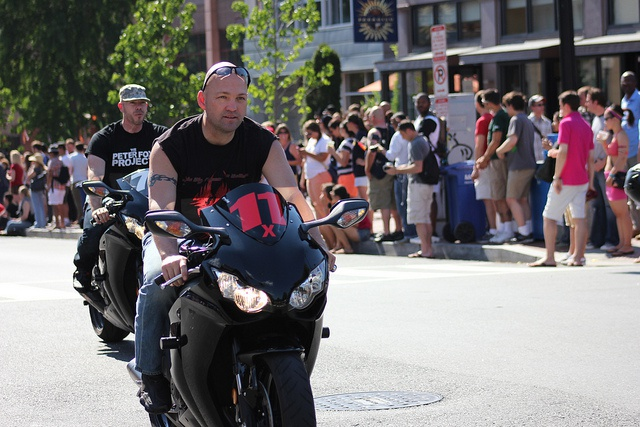Describe the objects in this image and their specific colors. I can see motorcycle in black, gray, navy, and white tones, people in black, gray, brown, and darkgray tones, people in black, gray, and white tones, people in black, gray, darkgray, and white tones, and motorcycle in black, gray, darkgray, and navy tones in this image. 